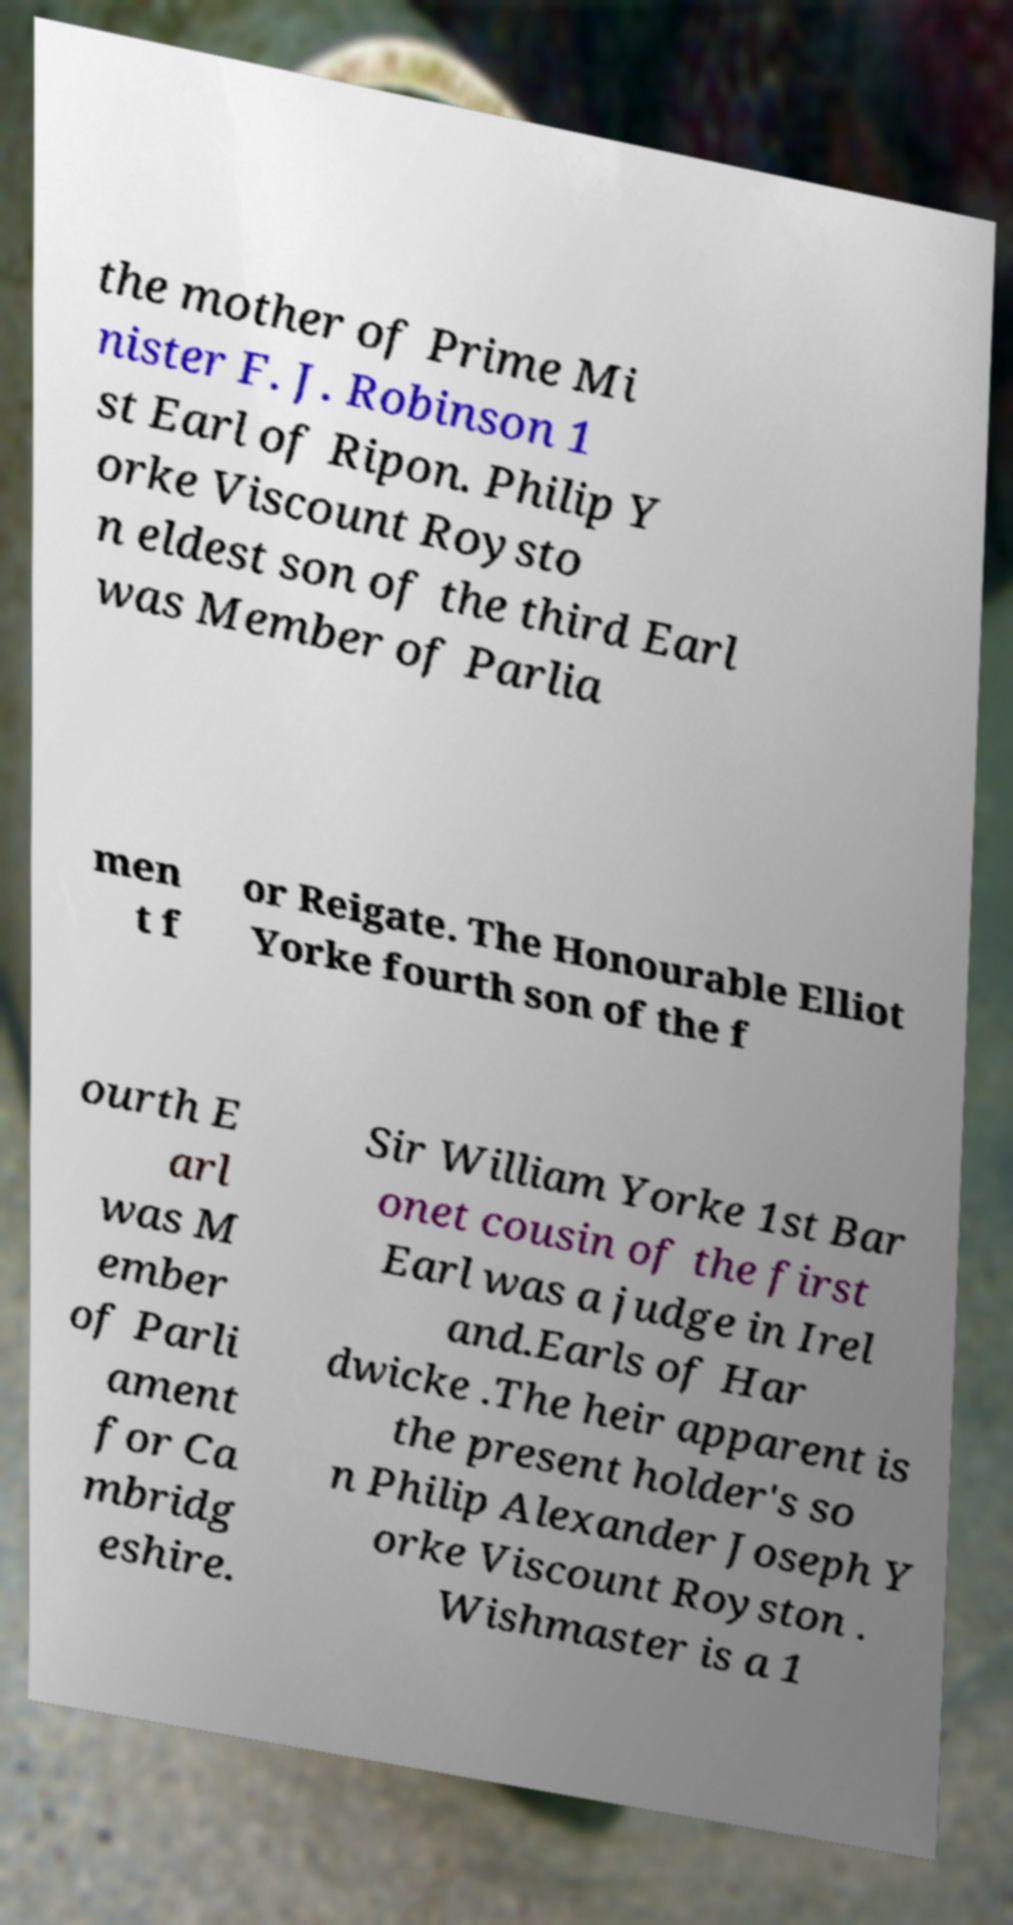There's text embedded in this image that I need extracted. Can you transcribe it verbatim? the mother of Prime Mi nister F. J. Robinson 1 st Earl of Ripon. Philip Y orke Viscount Roysto n eldest son of the third Earl was Member of Parlia men t f or Reigate. The Honourable Elliot Yorke fourth son of the f ourth E arl was M ember of Parli ament for Ca mbridg eshire. Sir William Yorke 1st Bar onet cousin of the first Earl was a judge in Irel and.Earls of Har dwicke .The heir apparent is the present holder's so n Philip Alexander Joseph Y orke Viscount Royston . Wishmaster is a 1 